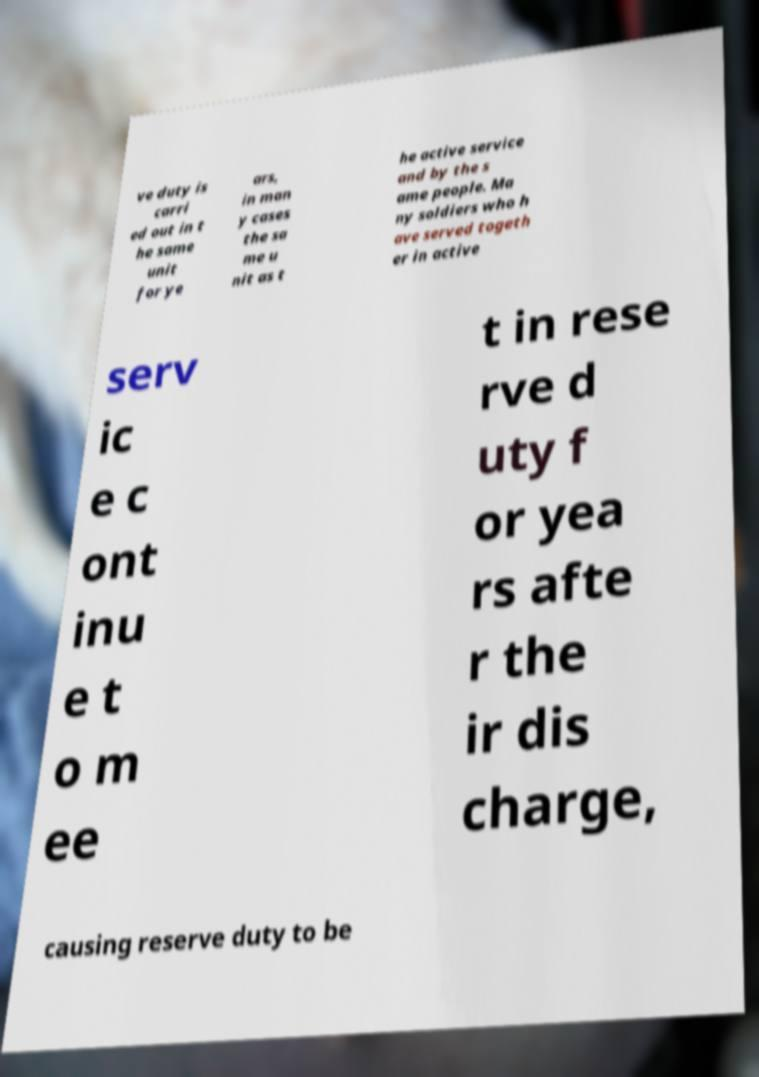Could you assist in decoding the text presented in this image and type it out clearly? ve duty is carri ed out in t he same unit for ye ars, in man y cases the sa me u nit as t he active service and by the s ame people. Ma ny soldiers who h ave served togeth er in active serv ic e c ont inu e t o m ee t in rese rve d uty f or yea rs afte r the ir dis charge, causing reserve duty to be 